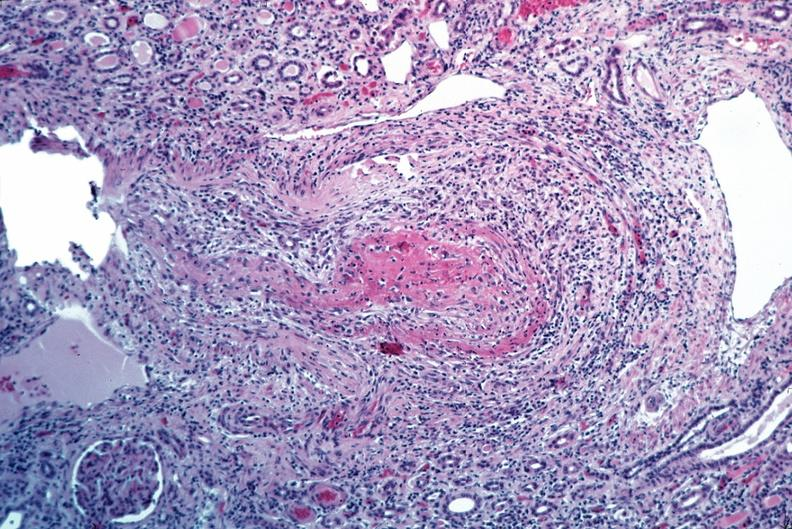what is present?
Answer the question using a single word or phrase. Cardiovascular 